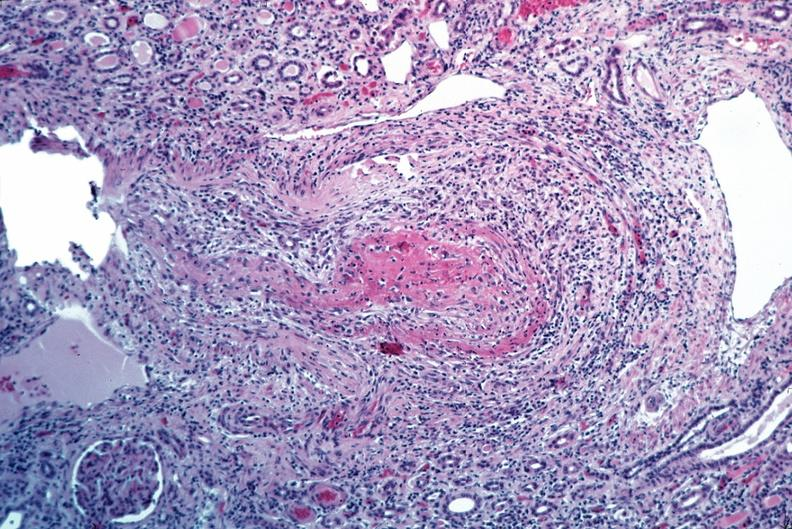what is present?
Answer the question using a single word or phrase. Cardiovascular 